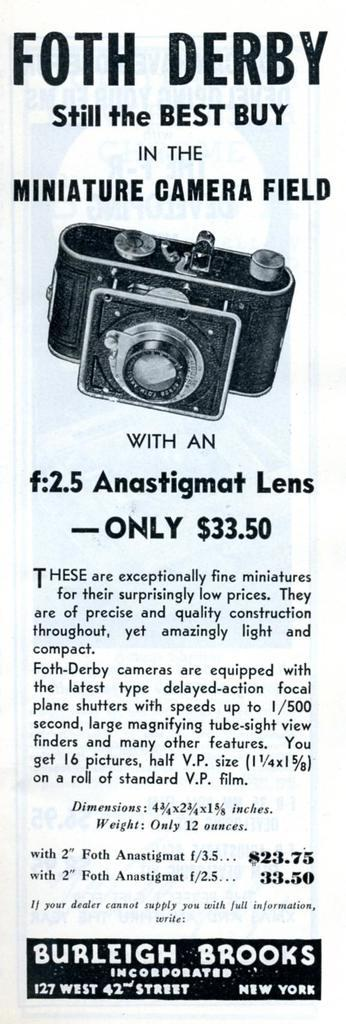What is present in the image that contains information or visuals? There is a poster in the image. What can be found on the poster besides the image? The poster contains text. What is the main image depicted on the poster? The poster has an image of a camera. How many yaks are visible in the image? There are no yaks present in the image. What type of plant is featured on the poster? The poster does not feature any plants; it has an image of a camera. 